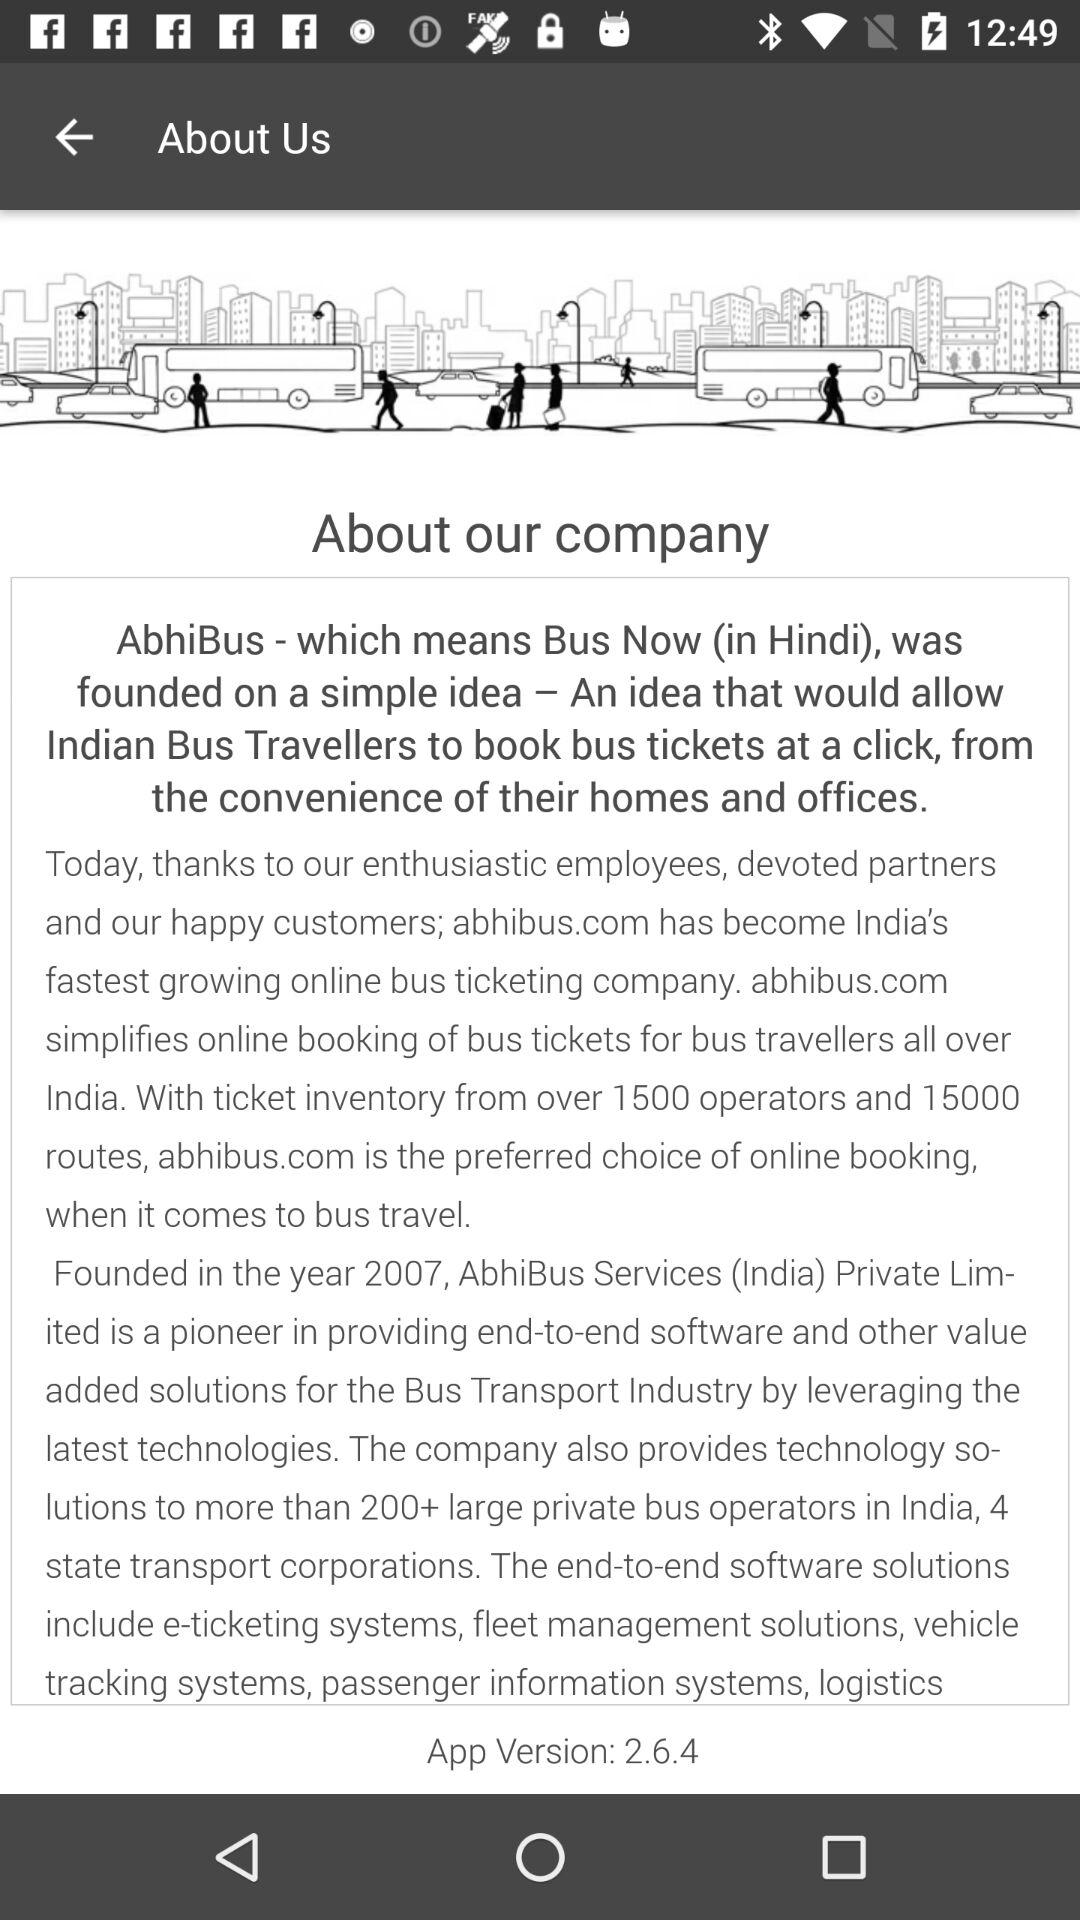What is the version of the app? The version of the app is 2.6.4. 